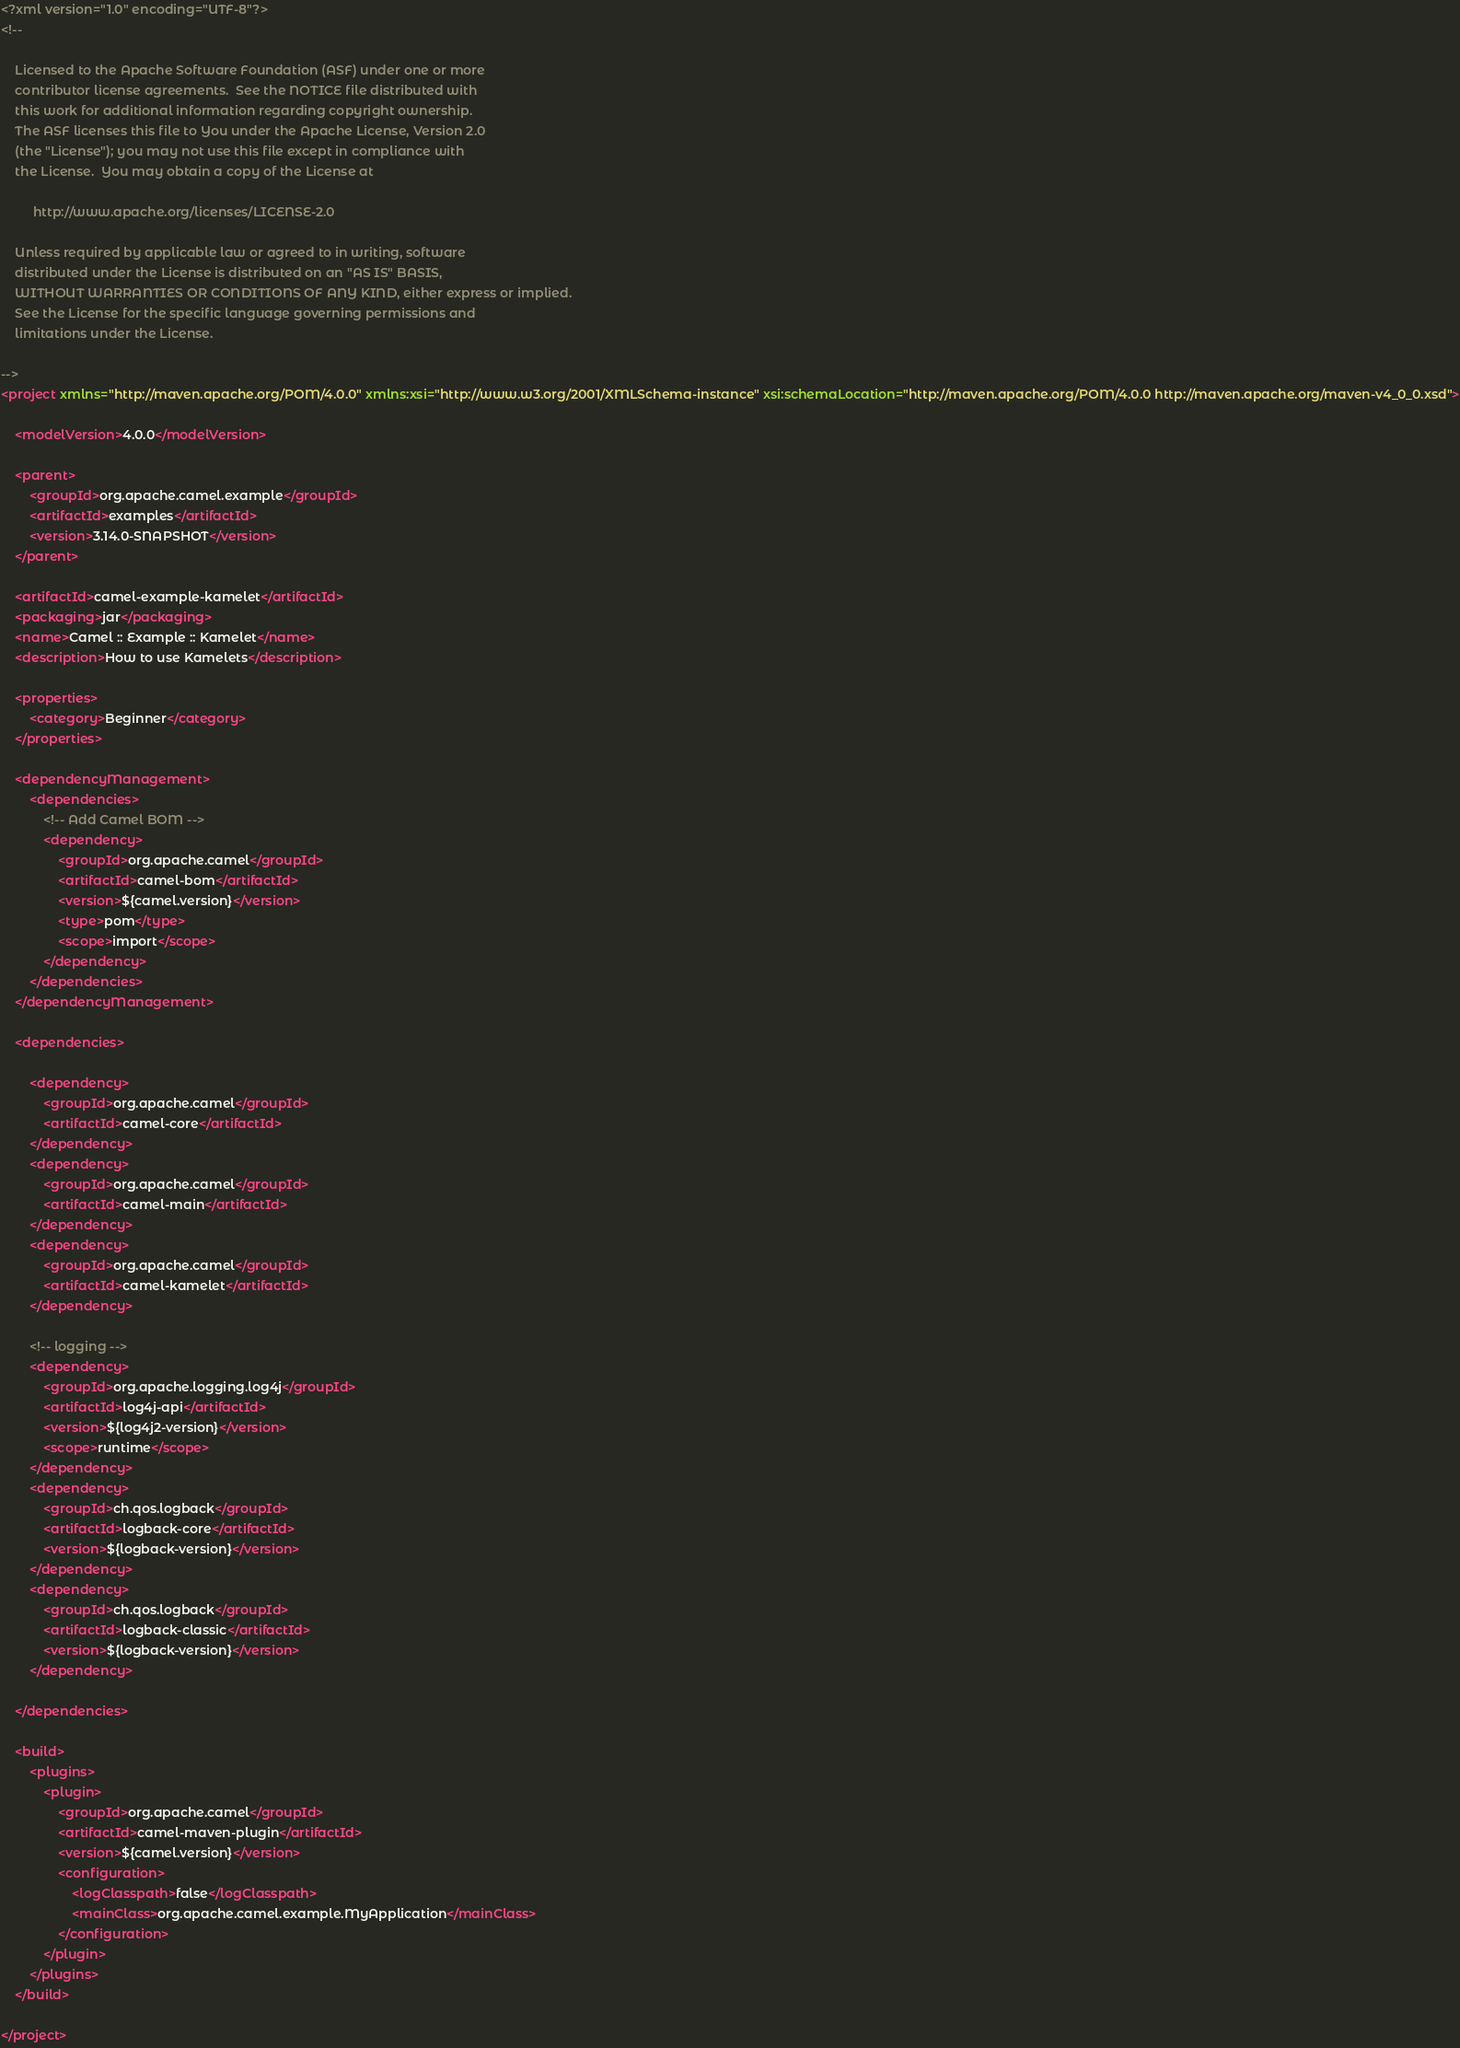<code> <loc_0><loc_0><loc_500><loc_500><_XML_><?xml version="1.0" encoding="UTF-8"?>
<!--

    Licensed to the Apache Software Foundation (ASF) under one or more
    contributor license agreements.  See the NOTICE file distributed with
    this work for additional information regarding copyright ownership.
    The ASF licenses this file to You under the Apache License, Version 2.0
    (the "License"); you may not use this file except in compliance with
    the License.  You may obtain a copy of the License at

         http://www.apache.org/licenses/LICENSE-2.0

    Unless required by applicable law or agreed to in writing, software
    distributed under the License is distributed on an "AS IS" BASIS,
    WITHOUT WARRANTIES OR CONDITIONS OF ANY KIND, either express or implied.
    See the License for the specific language governing permissions and
    limitations under the License.

-->
<project xmlns="http://maven.apache.org/POM/4.0.0" xmlns:xsi="http://www.w3.org/2001/XMLSchema-instance" xsi:schemaLocation="http://maven.apache.org/POM/4.0.0 http://maven.apache.org/maven-v4_0_0.xsd">

    <modelVersion>4.0.0</modelVersion>

    <parent>
        <groupId>org.apache.camel.example</groupId>
        <artifactId>examples</artifactId>
        <version>3.14.0-SNAPSHOT</version>
    </parent>

    <artifactId>camel-example-kamelet</artifactId>
    <packaging>jar</packaging>
    <name>Camel :: Example :: Kamelet</name>
    <description>How to use Kamelets</description>

    <properties>
        <category>Beginner</category>
    </properties>

    <dependencyManagement>
        <dependencies>
            <!-- Add Camel BOM -->
            <dependency>
                <groupId>org.apache.camel</groupId>
                <artifactId>camel-bom</artifactId>
                <version>${camel.version}</version>
                <type>pom</type>
                <scope>import</scope>
            </dependency>
        </dependencies>
    </dependencyManagement>

    <dependencies>

        <dependency>
            <groupId>org.apache.camel</groupId>
            <artifactId>camel-core</artifactId>
        </dependency>
        <dependency>
            <groupId>org.apache.camel</groupId>
            <artifactId>camel-main</artifactId>
        </dependency>
        <dependency>
            <groupId>org.apache.camel</groupId>
            <artifactId>camel-kamelet</artifactId>
        </dependency>

        <!-- logging -->
        <dependency>
            <groupId>org.apache.logging.log4j</groupId>
            <artifactId>log4j-api</artifactId>
            <version>${log4j2-version}</version>
            <scope>runtime</scope>
        </dependency>
        <dependency>
            <groupId>ch.qos.logback</groupId>
            <artifactId>logback-core</artifactId>
            <version>${logback-version}</version>
        </dependency>
        <dependency>
            <groupId>ch.qos.logback</groupId>
            <artifactId>logback-classic</artifactId>
            <version>${logback-version}</version>
        </dependency>

    </dependencies>

    <build>
        <plugins>
            <plugin>
                <groupId>org.apache.camel</groupId>
                <artifactId>camel-maven-plugin</artifactId>
                <version>${camel.version}</version>
                <configuration>
                    <logClasspath>false</logClasspath>
                    <mainClass>org.apache.camel.example.MyApplication</mainClass>
                </configuration>
            </plugin>
        </plugins>
    </build>

</project>
</code> 